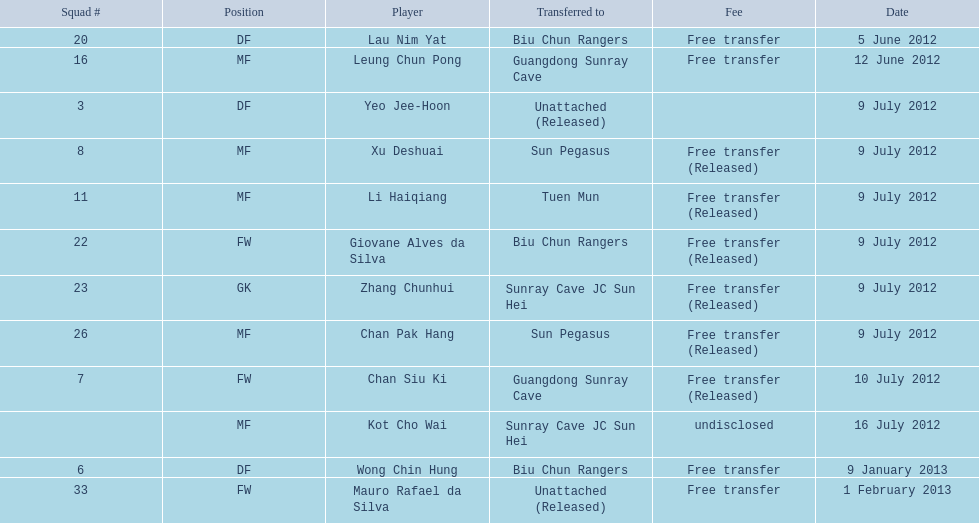On what dates were there non released free transfers? 5 June 2012, 12 June 2012, 9 January 2013, 1 February 2013. On which of these were the players transferred to another team? 5 June 2012, 12 June 2012, 9 January 2013. Which of these were the transfers to biu chun rangers? 5 June 2012, 9 January 2013. On which of those dated did they receive a df? 9 January 2013. 